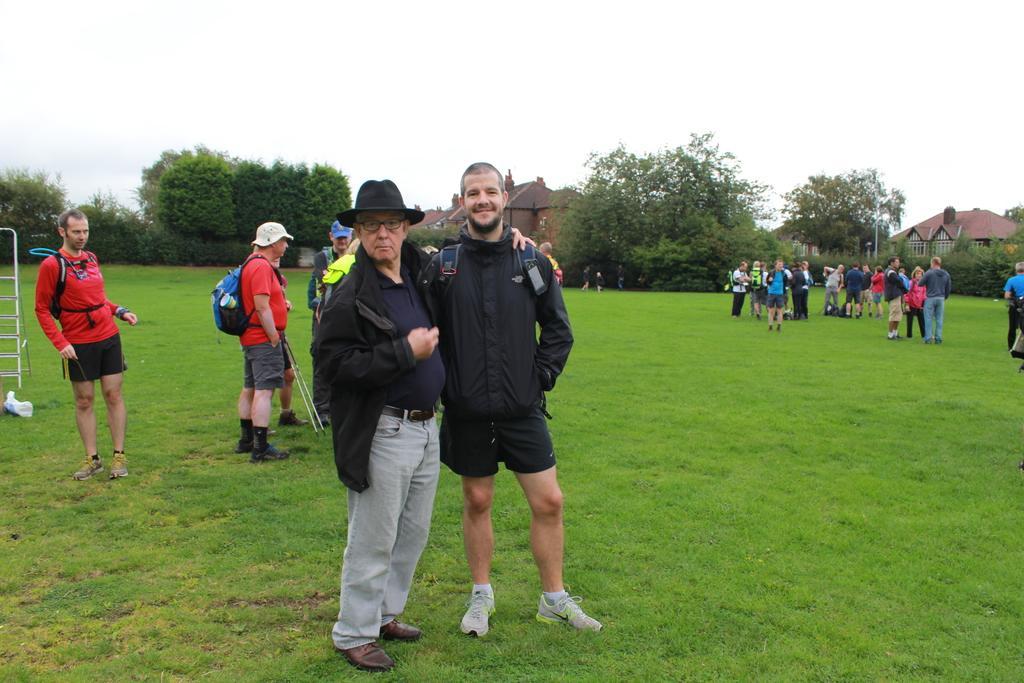In one or two sentences, can you explain what this image depicts? In the center of the image we can see a few people are standing and they are in different costumes. Among them, we can see one person is smiling and one person is wearing a hat and glasses. In the background, we can see the sky, clouds, buildings, trees, grass, few people and a few other objects. 